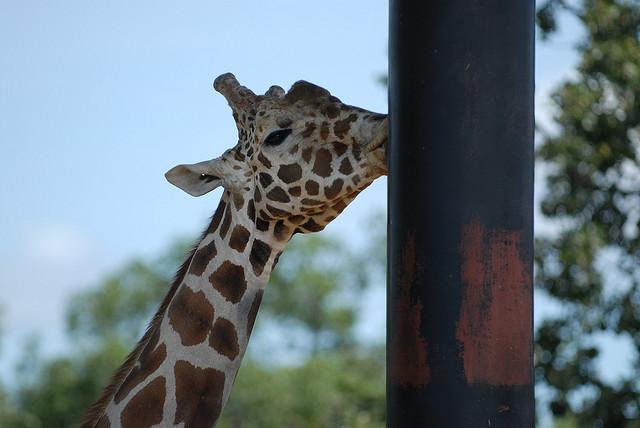Is the giraffe licking a tree?
Answer briefly. No. Does the giraffe have the horns?
Short answer required. Yes. What animal is this?
Concise answer only. Giraffe. 